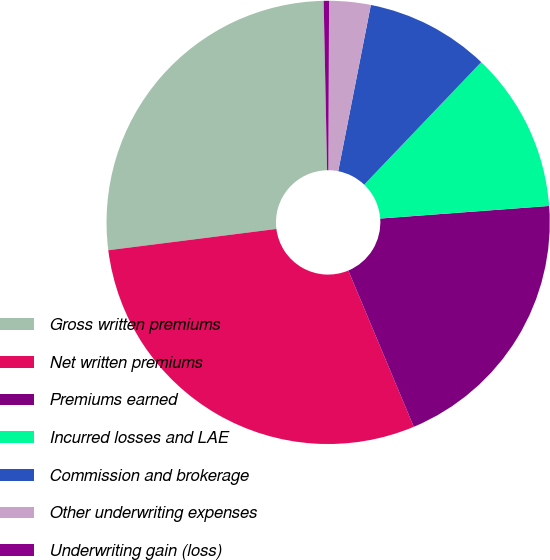Convert chart to OTSL. <chart><loc_0><loc_0><loc_500><loc_500><pie_chart><fcel>Gross written premiums<fcel>Net written premiums<fcel>Premiums earned<fcel>Incurred losses and LAE<fcel>Commission and brokerage<fcel>Other underwriting expenses<fcel>Underwriting gain (loss)<nl><fcel>26.68%<fcel>29.31%<fcel>19.87%<fcel>11.68%<fcel>9.05%<fcel>3.02%<fcel>0.39%<nl></chart> 